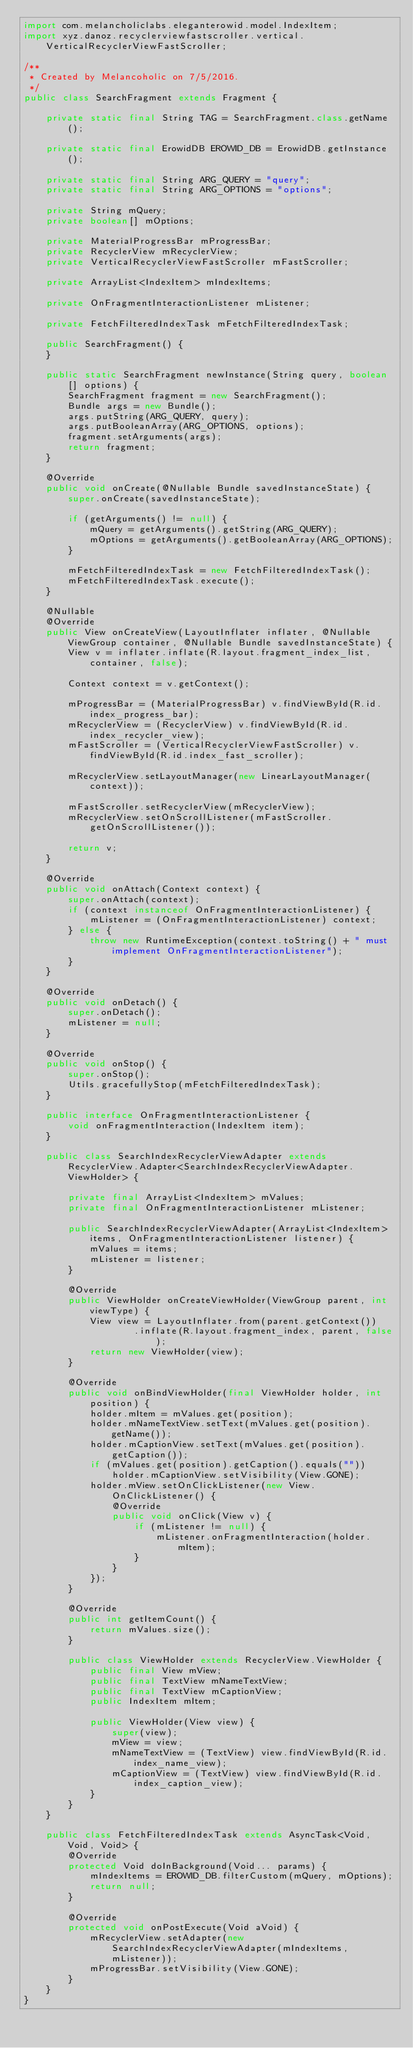<code> <loc_0><loc_0><loc_500><loc_500><_Java_>import com.melancholiclabs.eleganterowid.model.IndexItem;
import xyz.danoz.recyclerviewfastscroller.vertical.VerticalRecyclerViewFastScroller;

/**
 * Created by Melancoholic on 7/5/2016.
 */
public class SearchFragment extends Fragment {

    private static final String TAG = SearchFragment.class.getName();

    private static final ErowidDB EROWID_DB = ErowidDB.getInstance();

    private static final String ARG_QUERY = "query";
    private static final String ARG_OPTIONS = "options";

    private String mQuery;
    private boolean[] mOptions;

    private MaterialProgressBar mProgressBar;
    private RecyclerView mRecyclerView;
    private VerticalRecyclerViewFastScroller mFastScroller;

    private ArrayList<IndexItem> mIndexItems;

    private OnFragmentInteractionListener mListener;

    private FetchFilteredIndexTask mFetchFilteredIndexTask;

    public SearchFragment() {
    }

    public static SearchFragment newInstance(String query, boolean[] options) {
        SearchFragment fragment = new SearchFragment();
        Bundle args = new Bundle();
        args.putString(ARG_QUERY, query);
        args.putBooleanArray(ARG_OPTIONS, options);
        fragment.setArguments(args);
        return fragment;
    }

    @Override
    public void onCreate(@Nullable Bundle savedInstanceState) {
        super.onCreate(savedInstanceState);

        if (getArguments() != null) {
            mQuery = getArguments().getString(ARG_QUERY);
            mOptions = getArguments().getBooleanArray(ARG_OPTIONS);
        }

        mFetchFilteredIndexTask = new FetchFilteredIndexTask();
        mFetchFilteredIndexTask.execute();
    }

    @Nullable
    @Override
    public View onCreateView(LayoutInflater inflater, @Nullable ViewGroup container, @Nullable Bundle savedInstanceState) {
        View v = inflater.inflate(R.layout.fragment_index_list, container, false);

        Context context = v.getContext();

        mProgressBar = (MaterialProgressBar) v.findViewById(R.id.index_progress_bar);
        mRecyclerView = (RecyclerView) v.findViewById(R.id.index_recycler_view);
        mFastScroller = (VerticalRecyclerViewFastScroller) v.findViewById(R.id.index_fast_scroller);

        mRecyclerView.setLayoutManager(new LinearLayoutManager(context));

        mFastScroller.setRecyclerView(mRecyclerView);
        mRecyclerView.setOnScrollListener(mFastScroller.getOnScrollListener());

        return v;
    }

    @Override
    public void onAttach(Context context) {
        super.onAttach(context);
        if (context instanceof OnFragmentInteractionListener) {
            mListener = (OnFragmentInteractionListener) context;
        } else {
            throw new RuntimeException(context.toString() + " must implement OnFragmentInteractionListener");
        }
    }

    @Override
    public void onDetach() {
        super.onDetach();
        mListener = null;
    }

    @Override
    public void onStop() {
        super.onStop();
        Utils.gracefullyStop(mFetchFilteredIndexTask);
    }

    public interface OnFragmentInteractionListener {
        void onFragmentInteraction(IndexItem item);
    }

    public class SearchIndexRecyclerViewAdapter extends RecyclerView.Adapter<SearchIndexRecyclerViewAdapter.ViewHolder> {

        private final ArrayList<IndexItem> mValues;
        private final OnFragmentInteractionListener mListener;

        public SearchIndexRecyclerViewAdapter(ArrayList<IndexItem> items, OnFragmentInteractionListener listener) {
            mValues = items;
            mListener = listener;
        }

        @Override
        public ViewHolder onCreateViewHolder(ViewGroup parent, int viewType) {
            View view = LayoutInflater.from(parent.getContext())
                    .inflate(R.layout.fragment_index, parent, false);
            return new ViewHolder(view);
        }

        @Override
        public void onBindViewHolder(final ViewHolder holder, int position) {
            holder.mItem = mValues.get(position);
            holder.mNameTextView.setText(mValues.get(position).getName());
            holder.mCaptionView.setText(mValues.get(position).getCaption());
            if (mValues.get(position).getCaption().equals(""))
                holder.mCaptionView.setVisibility(View.GONE);
            holder.mView.setOnClickListener(new View.OnClickListener() {
                @Override
                public void onClick(View v) {
                    if (mListener != null) {
                        mListener.onFragmentInteraction(holder.mItem);
                    }
                }
            });
        }

        @Override
        public int getItemCount() {
            return mValues.size();
        }

        public class ViewHolder extends RecyclerView.ViewHolder {
            public final View mView;
            public final TextView mNameTextView;
            public final TextView mCaptionView;
            public IndexItem mItem;

            public ViewHolder(View view) {
                super(view);
                mView = view;
                mNameTextView = (TextView) view.findViewById(R.id.index_name_view);
                mCaptionView = (TextView) view.findViewById(R.id.index_caption_view);
            }
        }
    }

    public class FetchFilteredIndexTask extends AsyncTask<Void, Void, Void> {
        @Override
        protected Void doInBackground(Void... params) {
            mIndexItems = EROWID_DB.filterCustom(mQuery, mOptions);
            return null;
        }

        @Override
        protected void onPostExecute(Void aVoid) {
            mRecyclerView.setAdapter(new SearchIndexRecyclerViewAdapter(mIndexItems, mListener));
            mProgressBar.setVisibility(View.GONE);
        }
    }
}
</code> 